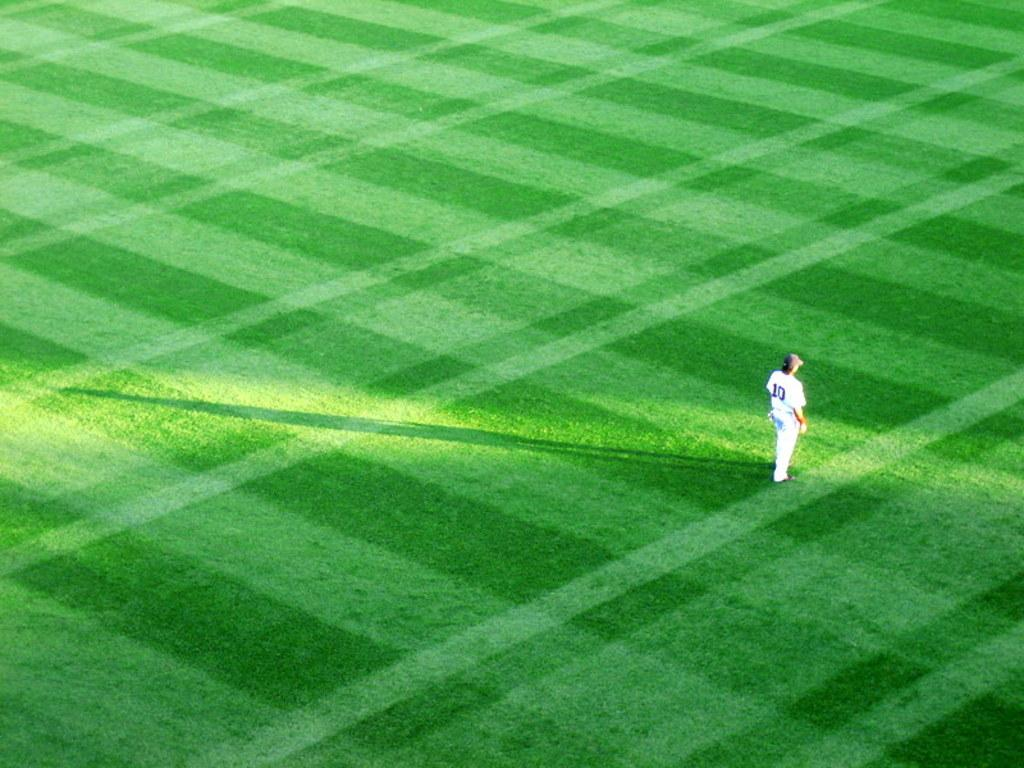What is the main subject of the image? The image depicts a playground. Can you describe the person visible in the image? There is a person on the right side of the image, and they are wearing a white dress and a cap on their head. Which direction is the person facing? The person is facing towards the right side. What type of furniture can be seen in the image? There is no furniture present in the image; it depicts a playground and a person. 